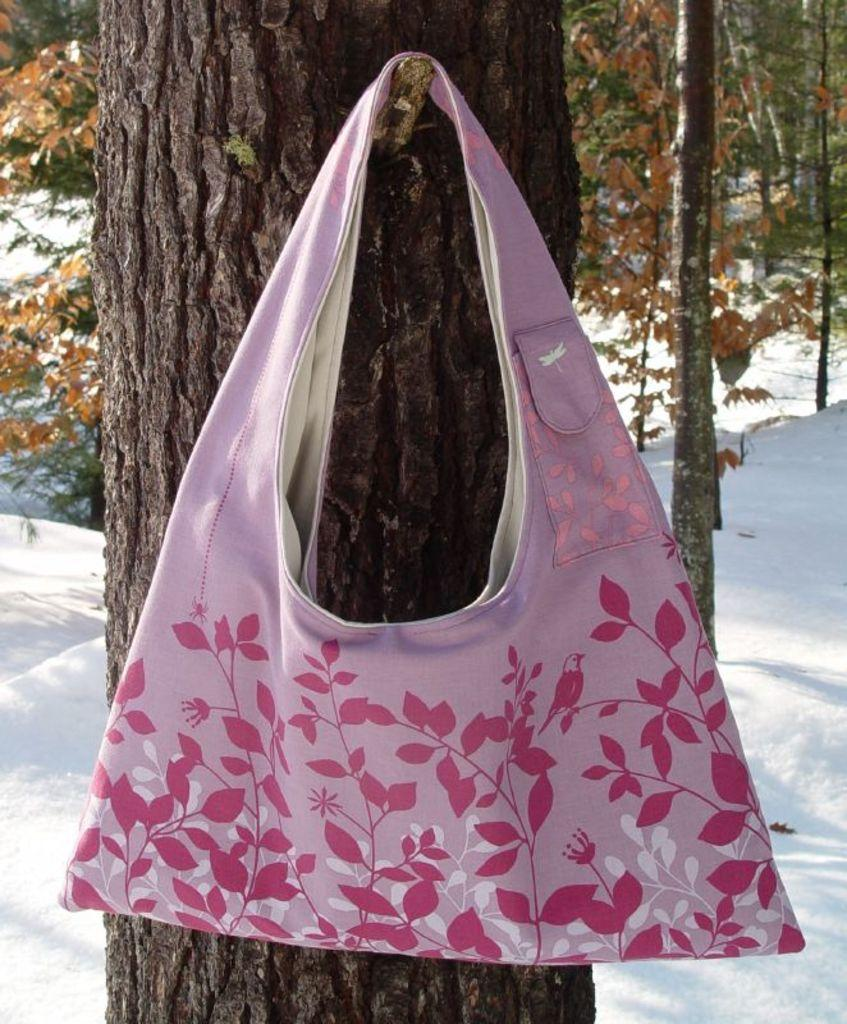What color is the handbag in the image? The handbag in the image is pink. Where is the handbag located? The handbag is hanging on a tree. What is the condition of the land in the image? The land is covered with snow. Can you see any stems growing from the handbag in the image? There are no stems growing from the handbag in the image. What type of ocean can be seen in the image? There is no ocean present in the image. 